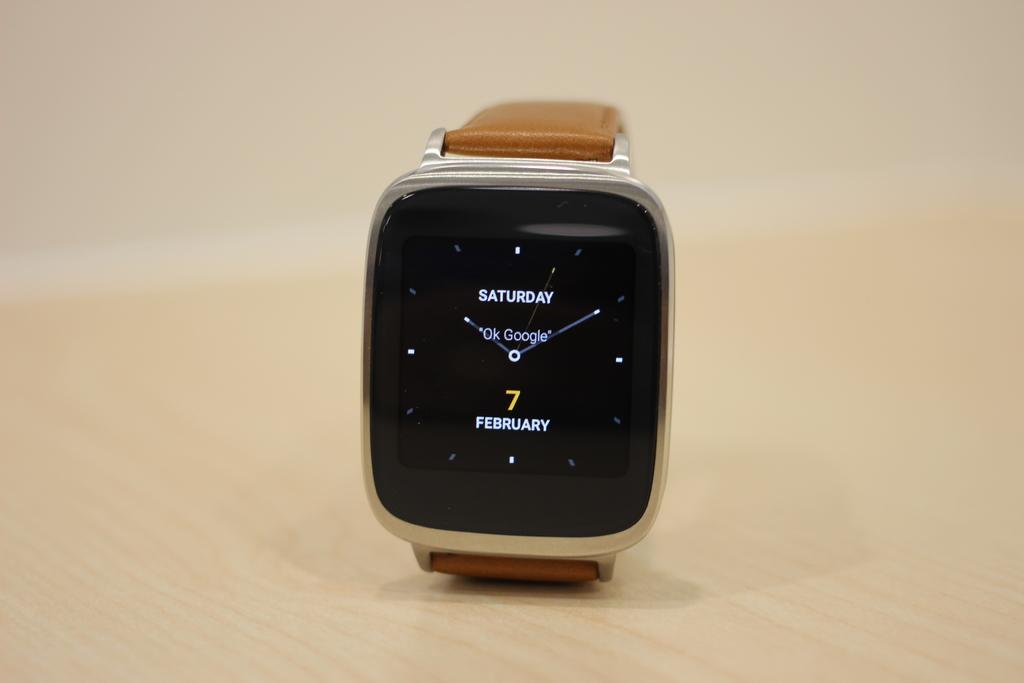<image>
Write a terse but informative summary of the picture. A google watch that shows Saturday, February 7 on it. 